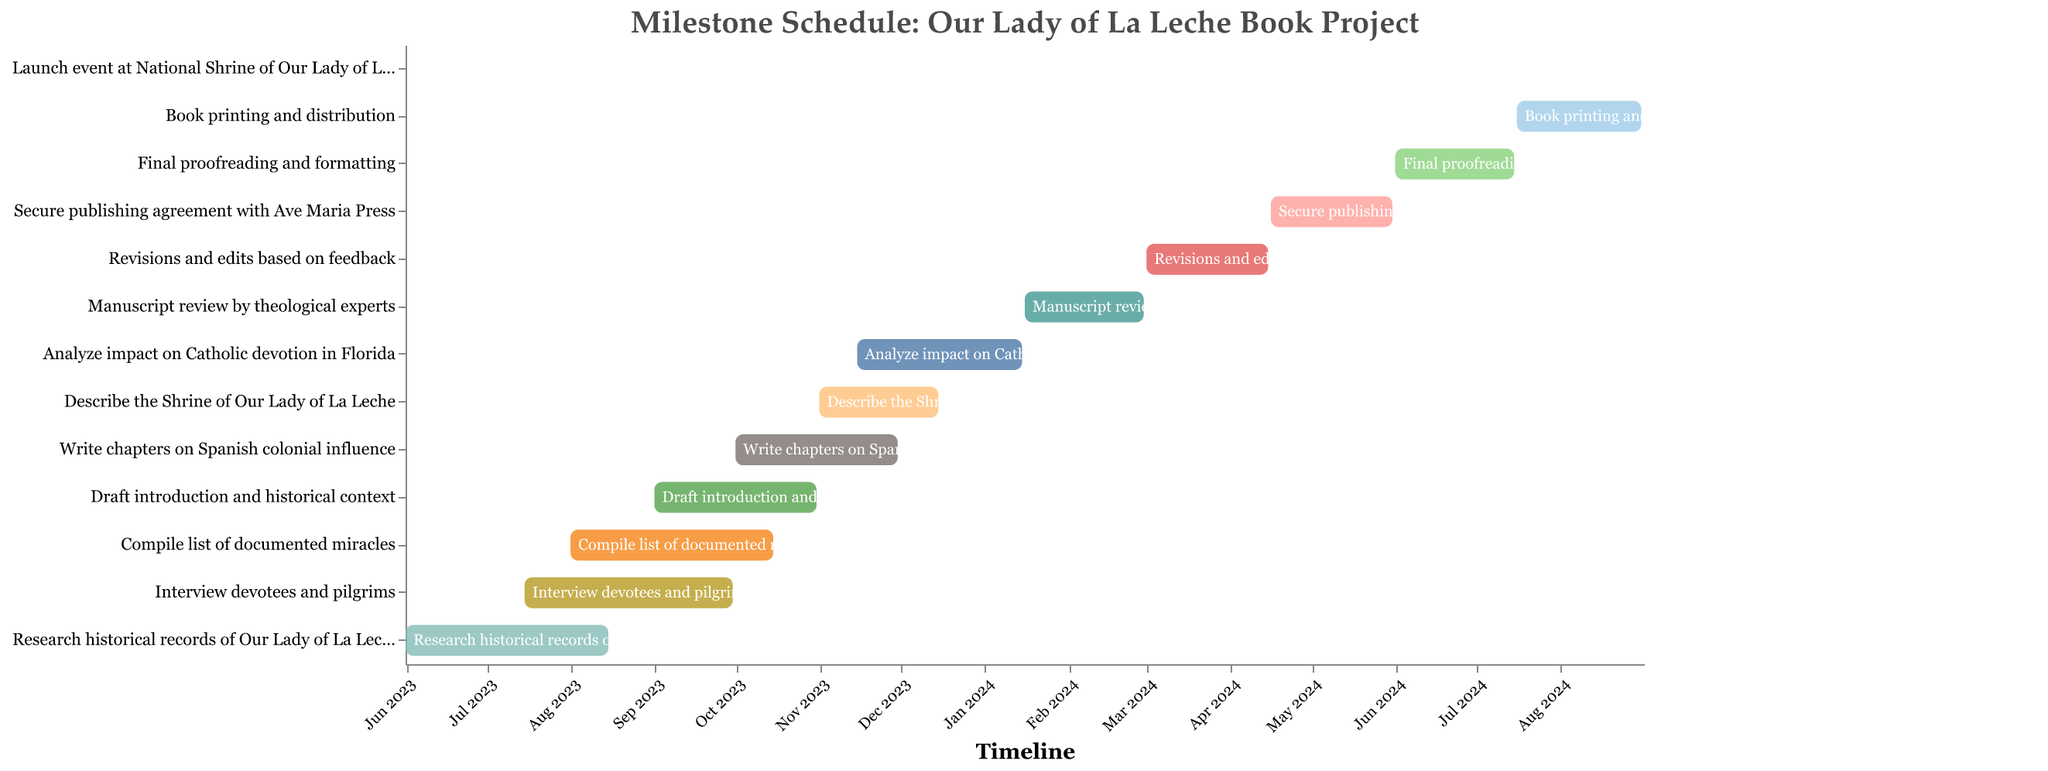What's the title of the Gantt Chart? The title is typically located at the top of the figure. In this case, it provides an overview of the project and reads: "Milestone Schedule: Our Lady of La Leche Book Project."
Answer: Milestone Schedule: Our Lady of La Leche Book Project How long will the task of "Research historical records of Our Lady of La Leche" take? To find this, look at the duration column for the respective task, which shows the number of days. The duration provided is 76 days.
Answer: 76 days When does the "Final proofreading and formatting" task begin and end? Check the start and end date columns for the task labeled "Final proofreading and formatting." According to the data, it starts on 2024-06-01 and ends on 2024-07-15.
Answer: 2024-06-01 to 2024-07-15 Which task has the shortest duration, and what is its length? Compare the duration column for all tasks to find the shortest one. The task "Launch event at National Shrine of Our Lady of La Leche" has the shortest duration, which is 1 day.
Answer: Launch event at National Shrine of Our Lady of La Leche, 1 day During what time period does the task "Analyze impact on Catholic devotion in Florida" overlap with the task "Describe the Shrine of Our Lady of La Leche"? Identify the start and end dates of both tasks and find the overlapping period. "Analyze impact on Catholic devotion in Florida" runs from 2023-11-15 to 2024-01-15, while "Describe the Shrine of Our Lady of La Leche" runs from 2023-11-01 to 2023-12-15. The overlapping period is from 2023-11-15 to 2023-12-15.
Answer: 2023-11-15 to 2023-12-15 How many tasks are scheduled to start in November 2023? Check the start date column for tasks starting in November 2023. There are two tasks: "Describe the Shrine of Our Lady of La Leche" (2023-11-01) and "Analyze impact on Catholic devotion in Florida" (2023-11-15).
Answer: 2 tasks What task will be ongoing during the entire month of December 2023? Identify tasks that cover the dates from December 1, 2023, to December 31, 2023. "Describe the Shrine of Our Lady of La Leche" covers 2023-11-01 to 2023-12-15, and "Analyze impact on Catholic devotion in Florida" covers 2023-11-15 to 2024-01-15. Only "Analyze impact on Catholic devotion in Florida" spans the entire month.
Answer: Analyze impact on Catholic devotion in Florida Which tasks will be in progress on January 1, 2024? Find tasks that include January 1, 2024, within their time range. "Analyze impact on Catholic devotion in Florida" (2023-11-15 to 2024-01-15) and "Manuscript review by theological experts" (2024-01-16 to 2024-02-29) are relevant; only the former covers January 1, 2024.
Answer: Analyze impact on Catholic devotion in Florida 